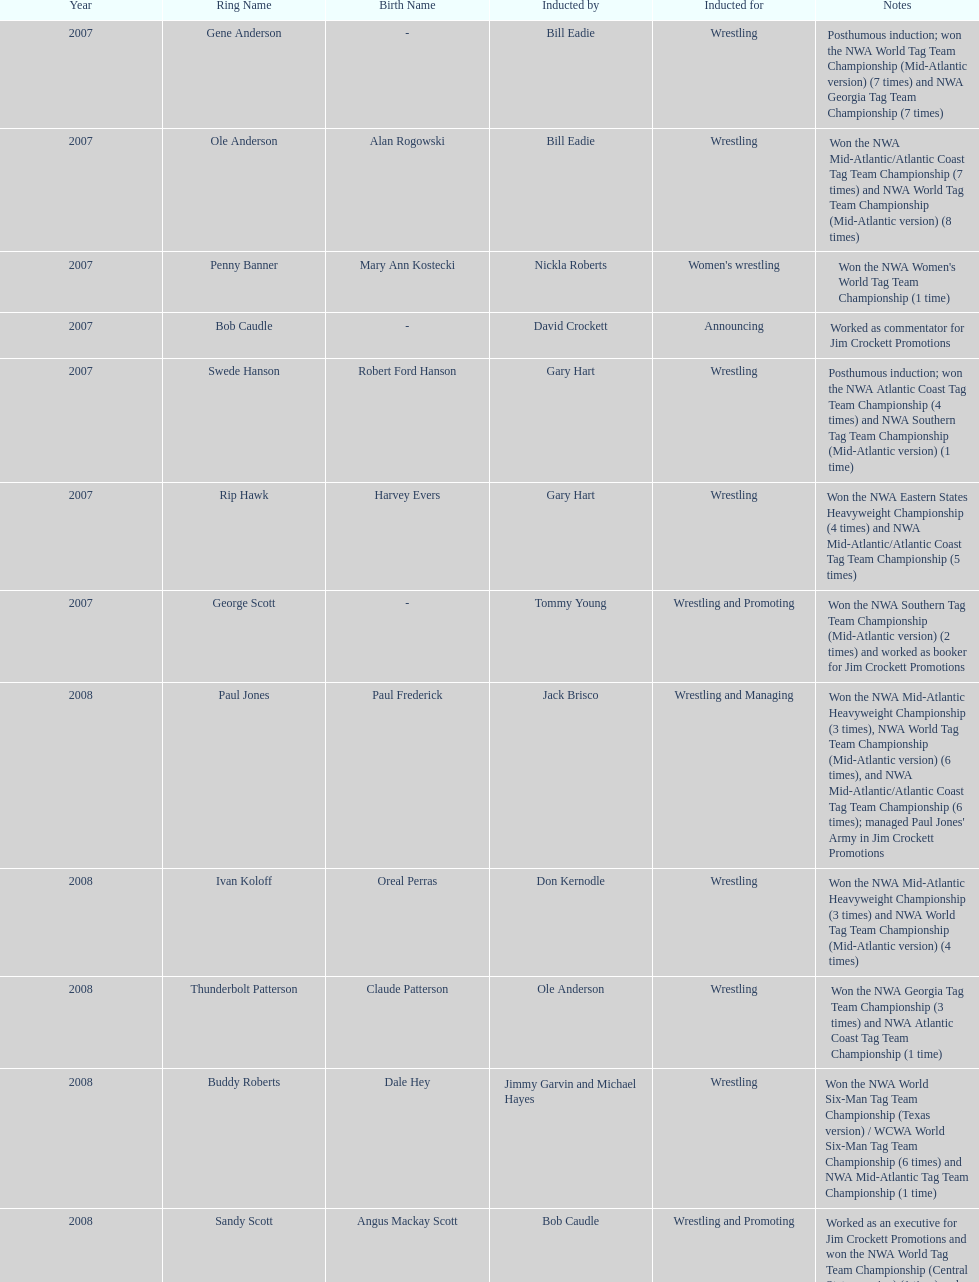How many members were inducted for announcing? 2. 